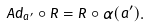Convert formula to latex. <formula><loc_0><loc_0><loc_500><loc_500>A d _ { a ^ { \prime } } \circ R = R \circ \alpha ( a ^ { \prime } ) .</formula> 